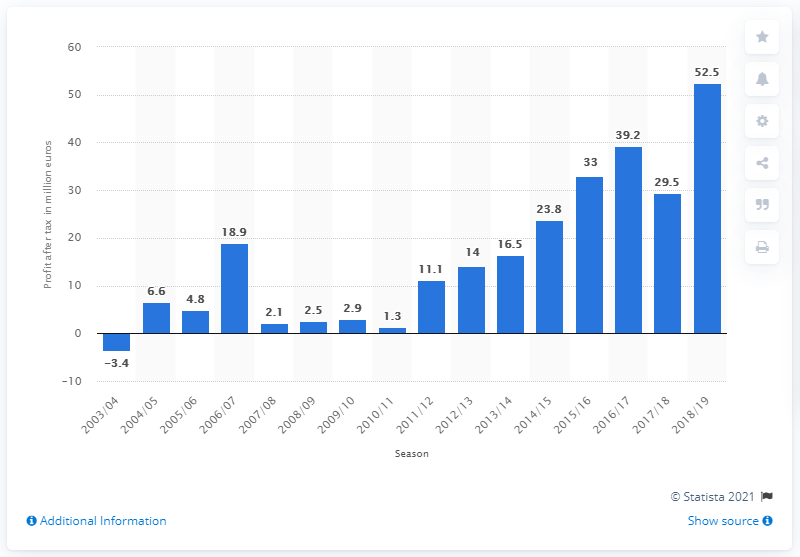Indicate a few pertinent items in this graphic. During the 2018 to 2019 financial year, Bayern Munich's total profit after tax was 52.5 million euros. 